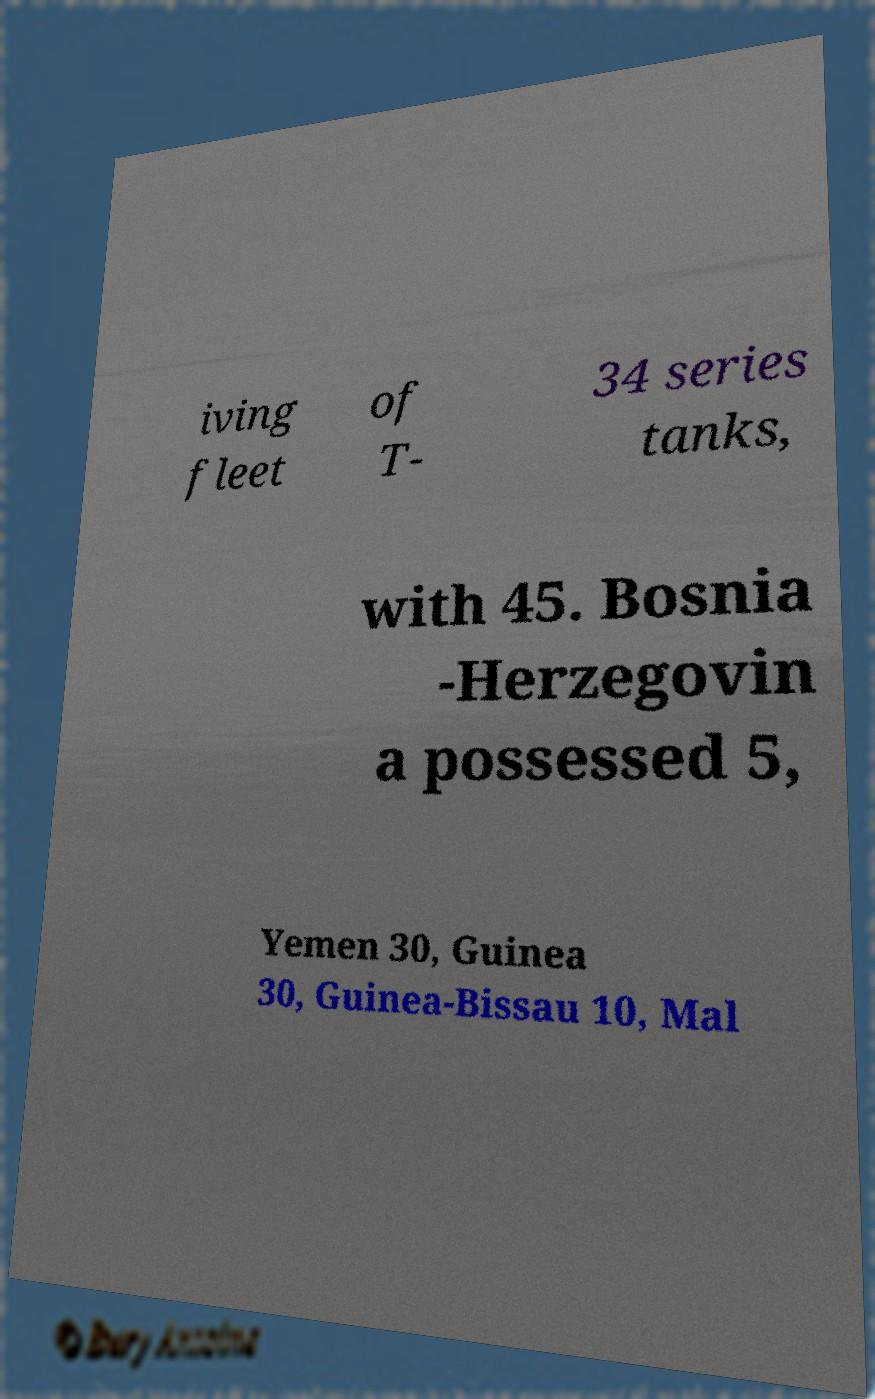Please identify and transcribe the text found in this image. iving fleet of T- 34 series tanks, with 45. Bosnia -Herzegovin a possessed 5, Yemen 30, Guinea 30, Guinea-Bissau 10, Mal 